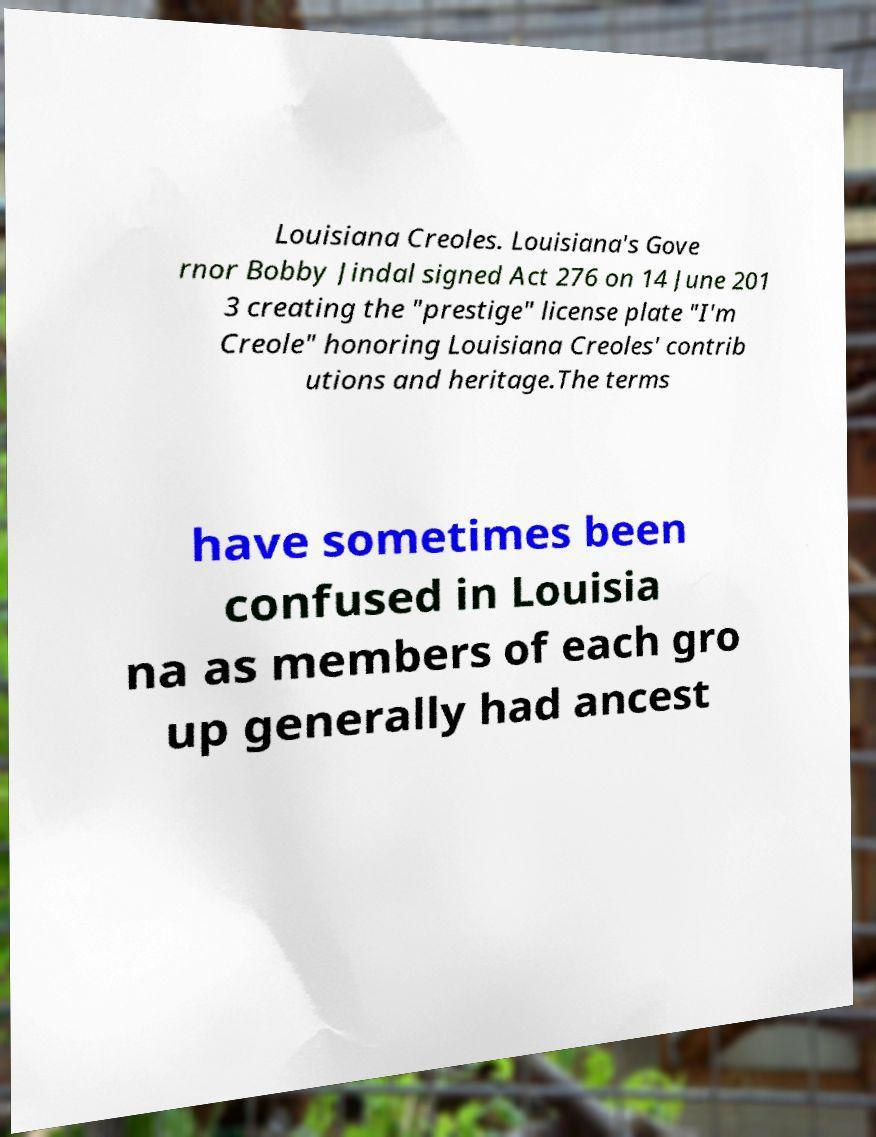What messages or text are displayed in this image? I need them in a readable, typed format. Louisiana Creoles. Louisiana's Gove rnor Bobby Jindal signed Act 276 on 14 June 201 3 creating the "prestige" license plate "I'm Creole" honoring Louisiana Creoles' contrib utions and heritage.The terms have sometimes been confused in Louisia na as members of each gro up generally had ancest 